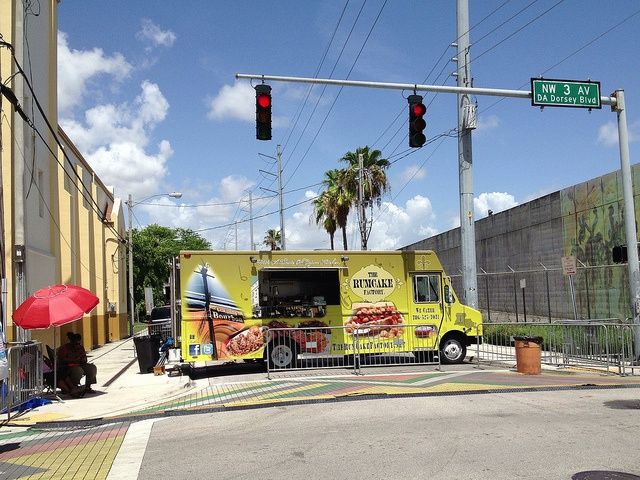Describe the objects in this image and their specific colors. I can see truck in tan, black, olive, khaki, and gray tones, umbrella in tan, brown, and salmon tones, people in tan, black, ivory, maroon, and gray tones, traffic light in tan, black, darkgray, red, and maroon tones, and traffic light in tan, black, maroon, and brown tones in this image. 